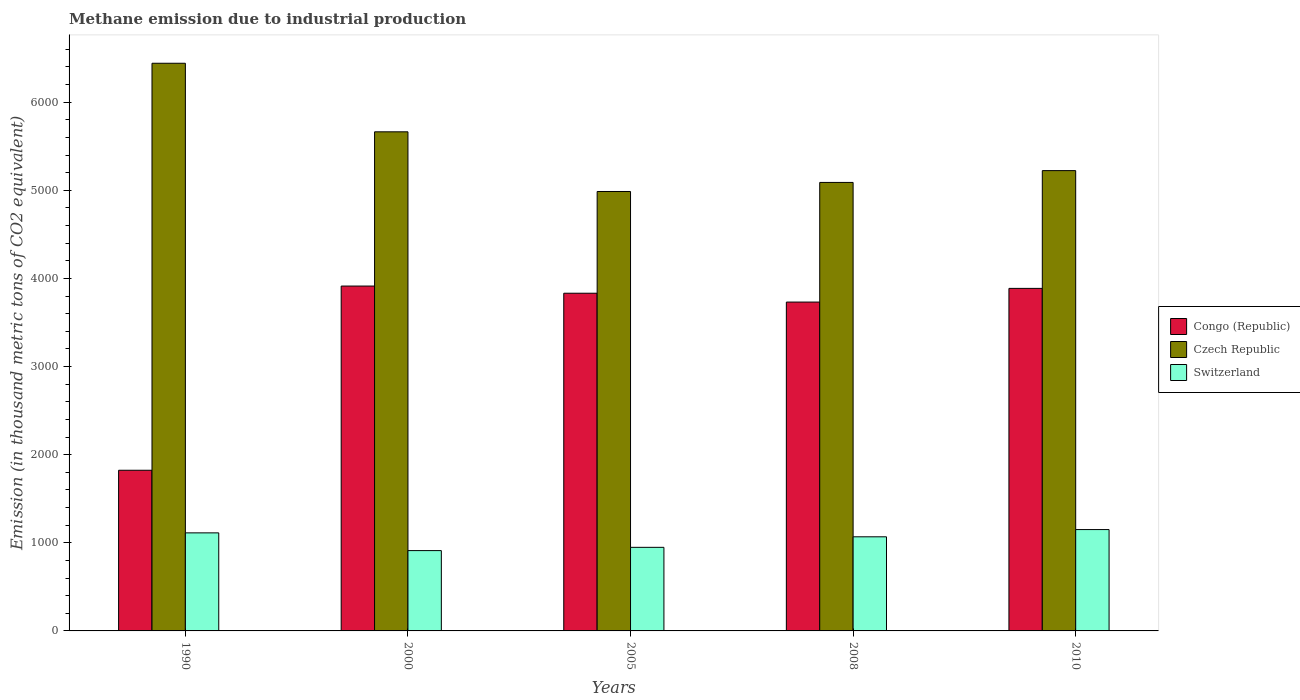How many different coloured bars are there?
Your answer should be compact. 3. How many groups of bars are there?
Provide a succinct answer. 5. Are the number of bars per tick equal to the number of legend labels?
Provide a succinct answer. Yes. Are the number of bars on each tick of the X-axis equal?
Offer a very short reply. Yes. How many bars are there on the 1st tick from the right?
Ensure brevity in your answer.  3. What is the amount of methane emitted in Czech Republic in 1990?
Make the answer very short. 6442.2. Across all years, what is the maximum amount of methane emitted in Switzerland?
Provide a short and direct response. 1150.2. Across all years, what is the minimum amount of methane emitted in Czech Republic?
Offer a terse response. 4986.9. What is the total amount of methane emitted in Congo (Republic) in the graph?
Offer a terse response. 1.72e+04. What is the difference between the amount of methane emitted in Congo (Republic) in 2000 and that in 2005?
Provide a short and direct response. 81.3. What is the difference between the amount of methane emitted in Congo (Republic) in 2000 and the amount of methane emitted in Czech Republic in 1990?
Offer a very short reply. -2528.5. What is the average amount of methane emitted in Czech Republic per year?
Ensure brevity in your answer.  5481.36. In the year 2000, what is the difference between the amount of methane emitted in Congo (Republic) and amount of methane emitted in Switzerland?
Your answer should be very brief. 3002.1. In how many years, is the amount of methane emitted in Czech Republic greater than 5400 thousand metric tons?
Give a very brief answer. 2. What is the ratio of the amount of methane emitted in Congo (Republic) in 2000 to that in 2005?
Provide a succinct answer. 1.02. Is the amount of methane emitted in Switzerland in 1990 less than that in 2000?
Your answer should be compact. No. What is the difference between the highest and the second highest amount of methane emitted in Congo (Republic)?
Provide a succinct answer. 26.4. What is the difference between the highest and the lowest amount of methane emitted in Czech Republic?
Make the answer very short. 1455.3. In how many years, is the amount of methane emitted in Switzerland greater than the average amount of methane emitted in Switzerland taken over all years?
Your answer should be compact. 3. What does the 1st bar from the left in 1990 represents?
Offer a very short reply. Congo (Republic). What does the 2nd bar from the right in 2005 represents?
Ensure brevity in your answer.  Czech Republic. Is it the case that in every year, the sum of the amount of methane emitted in Switzerland and amount of methane emitted in Congo (Republic) is greater than the amount of methane emitted in Czech Republic?
Keep it short and to the point. No. How many bars are there?
Your answer should be compact. 15. Are the values on the major ticks of Y-axis written in scientific E-notation?
Ensure brevity in your answer.  No. Does the graph contain any zero values?
Make the answer very short. No. Does the graph contain grids?
Offer a very short reply. No. Where does the legend appear in the graph?
Offer a very short reply. Center right. How many legend labels are there?
Provide a succinct answer. 3. How are the legend labels stacked?
Your answer should be compact. Vertical. What is the title of the graph?
Your answer should be very brief. Methane emission due to industrial production. Does "Estonia" appear as one of the legend labels in the graph?
Provide a short and direct response. No. What is the label or title of the Y-axis?
Your response must be concise. Emission (in thousand metric tons of CO2 equivalent). What is the Emission (in thousand metric tons of CO2 equivalent) of Congo (Republic) in 1990?
Your answer should be compact. 1823.3. What is the Emission (in thousand metric tons of CO2 equivalent) in Czech Republic in 1990?
Give a very brief answer. 6442.2. What is the Emission (in thousand metric tons of CO2 equivalent) in Switzerland in 1990?
Give a very brief answer. 1112.7. What is the Emission (in thousand metric tons of CO2 equivalent) in Congo (Republic) in 2000?
Offer a terse response. 3913.7. What is the Emission (in thousand metric tons of CO2 equivalent) of Czech Republic in 2000?
Your answer should be compact. 5664.2. What is the Emission (in thousand metric tons of CO2 equivalent) in Switzerland in 2000?
Your answer should be very brief. 911.6. What is the Emission (in thousand metric tons of CO2 equivalent) of Congo (Republic) in 2005?
Keep it short and to the point. 3832.4. What is the Emission (in thousand metric tons of CO2 equivalent) of Czech Republic in 2005?
Your answer should be compact. 4986.9. What is the Emission (in thousand metric tons of CO2 equivalent) of Switzerland in 2005?
Provide a succinct answer. 948.6. What is the Emission (in thousand metric tons of CO2 equivalent) of Congo (Republic) in 2008?
Provide a short and direct response. 3732. What is the Emission (in thousand metric tons of CO2 equivalent) in Czech Republic in 2008?
Provide a succinct answer. 5089.7. What is the Emission (in thousand metric tons of CO2 equivalent) of Switzerland in 2008?
Keep it short and to the point. 1068.1. What is the Emission (in thousand metric tons of CO2 equivalent) in Congo (Republic) in 2010?
Provide a succinct answer. 3887.3. What is the Emission (in thousand metric tons of CO2 equivalent) of Czech Republic in 2010?
Make the answer very short. 5223.8. What is the Emission (in thousand metric tons of CO2 equivalent) in Switzerland in 2010?
Make the answer very short. 1150.2. Across all years, what is the maximum Emission (in thousand metric tons of CO2 equivalent) of Congo (Republic)?
Offer a terse response. 3913.7. Across all years, what is the maximum Emission (in thousand metric tons of CO2 equivalent) of Czech Republic?
Ensure brevity in your answer.  6442.2. Across all years, what is the maximum Emission (in thousand metric tons of CO2 equivalent) of Switzerland?
Keep it short and to the point. 1150.2. Across all years, what is the minimum Emission (in thousand metric tons of CO2 equivalent) of Congo (Republic)?
Your response must be concise. 1823.3. Across all years, what is the minimum Emission (in thousand metric tons of CO2 equivalent) of Czech Republic?
Make the answer very short. 4986.9. Across all years, what is the minimum Emission (in thousand metric tons of CO2 equivalent) of Switzerland?
Offer a terse response. 911.6. What is the total Emission (in thousand metric tons of CO2 equivalent) of Congo (Republic) in the graph?
Ensure brevity in your answer.  1.72e+04. What is the total Emission (in thousand metric tons of CO2 equivalent) in Czech Republic in the graph?
Your response must be concise. 2.74e+04. What is the total Emission (in thousand metric tons of CO2 equivalent) in Switzerland in the graph?
Keep it short and to the point. 5191.2. What is the difference between the Emission (in thousand metric tons of CO2 equivalent) in Congo (Republic) in 1990 and that in 2000?
Offer a terse response. -2090.4. What is the difference between the Emission (in thousand metric tons of CO2 equivalent) in Czech Republic in 1990 and that in 2000?
Your answer should be compact. 778. What is the difference between the Emission (in thousand metric tons of CO2 equivalent) in Switzerland in 1990 and that in 2000?
Provide a short and direct response. 201.1. What is the difference between the Emission (in thousand metric tons of CO2 equivalent) of Congo (Republic) in 1990 and that in 2005?
Keep it short and to the point. -2009.1. What is the difference between the Emission (in thousand metric tons of CO2 equivalent) of Czech Republic in 1990 and that in 2005?
Your answer should be compact. 1455.3. What is the difference between the Emission (in thousand metric tons of CO2 equivalent) in Switzerland in 1990 and that in 2005?
Your answer should be compact. 164.1. What is the difference between the Emission (in thousand metric tons of CO2 equivalent) of Congo (Republic) in 1990 and that in 2008?
Ensure brevity in your answer.  -1908.7. What is the difference between the Emission (in thousand metric tons of CO2 equivalent) of Czech Republic in 1990 and that in 2008?
Your response must be concise. 1352.5. What is the difference between the Emission (in thousand metric tons of CO2 equivalent) of Switzerland in 1990 and that in 2008?
Keep it short and to the point. 44.6. What is the difference between the Emission (in thousand metric tons of CO2 equivalent) of Congo (Republic) in 1990 and that in 2010?
Your response must be concise. -2064. What is the difference between the Emission (in thousand metric tons of CO2 equivalent) in Czech Republic in 1990 and that in 2010?
Offer a terse response. 1218.4. What is the difference between the Emission (in thousand metric tons of CO2 equivalent) in Switzerland in 1990 and that in 2010?
Ensure brevity in your answer.  -37.5. What is the difference between the Emission (in thousand metric tons of CO2 equivalent) of Congo (Republic) in 2000 and that in 2005?
Your answer should be very brief. 81.3. What is the difference between the Emission (in thousand metric tons of CO2 equivalent) of Czech Republic in 2000 and that in 2005?
Make the answer very short. 677.3. What is the difference between the Emission (in thousand metric tons of CO2 equivalent) of Switzerland in 2000 and that in 2005?
Your answer should be compact. -37. What is the difference between the Emission (in thousand metric tons of CO2 equivalent) of Congo (Republic) in 2000 and that in 2008?
Your answer should be compact. 181.7. What is the difference between the Emission (in thousand metric tons of CO2 equivalent) of Czech Republic in 2000 and that in 2008?
Your answer should be compact. 574.5. What is the difference between the Emission (in thousand metric tons of CO2 equivalent) of Switzerland in 2000 and that in 2008?
Ensure brevity in your answer.  -156.5. What is the difference between the Emission (in thousand metric tons of CO2 equivalent) of Congo (Republic) in 2000 and that in 2010?
Ensure brevity in your answer.  26.4. What is the difference between the Emission (in thousand metric tons of CO2 equivalent) in Czech Republic in 2000 and that in 2010?
Provide a short and direct response. 440.4. What is the difference between the Emission (in thousand metric tons of CO2 equivalent) in Switzerland in 2000 and that in 2010?
Provide a short and direct response. -238.6. What is the difference between the Emission (in thousand metric tons of CO2 equivalent) in Congo (Republic) in 2005 and that in 2008?
Offer a very short reply. 100.4. What is the difference between the Emission (in thousand metric tons of CO2 equivalent) of Czech Republic in 2005 and that in 2008?
Your answer should be compact. -102.8. What is the difference between the Emission (in thousand metric tons of CO2 equivalent) of Switzerland in 2005 and that in 2008?
Your response must be concise. -119.5. What is the difference between the Emission (in thousand metric tons of CO2 equivalent) in Congo (Republic) in 2005 and that in 2010?
Keep it short and to the point. -54.9. What is the difference between the Emission (in thousand metric tons of CO2 equivalent) in Czech Republic in 2005 and that in 2010?
Provide a short and direct response. -236.9. What is the difference between the Emission (in thousand metric tons of CO2 equivalent) in Switzerland in 2005 and that in 2010?
Ensure brevity in your answer.  -201.6. What is the difference between the Emission (in thousand metric tons of CO2 equivalent) of Congo (Republic) in 2008 and that in 2010?
Your answer should be compact. -155.3. What is the difference between the Emission (in thousand metric tons of CO2 equivalent) of Czech Republic in 2008 and that in 2010?
Offer a very short reply. -134.1. What is the difference between the Emission (in thousand metric tons of CO2 equivalent) of Switzerland in 2008 and that in 2010?
Provide a short and direct response. -82.1. What is the difference between the Emission (in thousand metric tons of CO2 equivalent) in Congo (Republic) in 1990 and the Emission (in thousand metric tons of CO2 equivalent) in Czech Republic in 2000?
Your answer should be compact. -3840.9. What is the difference between the Emission (in thousand metric tons of CO2 equivalent) in Congo (Republic) in 1990 and the Emission (in thousand metric tons of CO2 equivalent) in Switzerland in 2000?
Provide a succinct answer. 911.7. What is the difference between the Emission (in thousand metric tons of CO2 equivalent) in Czech Republic in 1990 and the Emission (in thousand metric tons of CO2 equivalent) in Switzerland in 2000?
Make the answer very short. 5530.6. What is the difference between the Emission (in thousand metric tons of CO2 equivalent) of Congo (Republic) in 1990 and the Emission (in thousand metric tons of CO2 equivalent) of Czech Republic in 2005?
Offer a very short reply. -3163.6. What is the difference between the Emission (in thousand metric tons of CO2 equivalent) in Congo (Republic) in 1990 and the Emission (in thousand metric tons of CO2 equivalent) in Switzerland in 2005?
Provide a succinct answer. 874.7. What is the difference between the Emission (in thousand metric tons of CO2 equivalent) of Czech Republic in 1990 and the Emission (in thousand metric tons of CO2 equivalent) of Switzerland in 2005?
Your answer should be compact. 5493.6. What is the difference between the Emission (in thousand metric tons of CO2 equivalent) in Congo (Republic) in 1990 and the Emission (in thousand metric tons of CO2 equivalent) in Czech Republic in 2008?
Provide a short and direct response. -3266.4. What is the difference between the Emission (in thousand metric tons of CO2 equivalent) of Congo (Republic) in 1990 and the Emission (in thousand metric tons of CO2 equivalent) of Switzerland in 2008?
Your answer should be compact. 755.2. What is the difference between the Emission (in thousand metric tons of CO2 equivalent) of Czech Republic in 1990 and the Emission (in thousand metric tons of CO2 equivalent) of Switzerland in 2008?
Offer a terse response. 5374.1. What is the difference between the Emission (in thousand metric tons of CO2 equivalent) in Congo (Republic) in 1990 and the Emission (in thousand metric tons of CO2 equivalent) in Czech Republic in 2010?
Provide a succinct answer. -3400.5. What is the difference between the Emission (in thousand metric tons of CO2 equivalent) in Congo (Republic) in 1990 and the Emission (in thousand metric tons of CO2 equivalent) in Switzerland in 2010?
Keep it short and to the point. 673.1. What is the difference between the Emission (in thousand metric tons of CO2 equivalent) in Czech Republic in 1990 and the Emission (in thousand metric tons of CO2 equivalent) in Switzerland in 2010?
Keep it short and to the point. 5292. What is the difference between the Emission (in thousand metric tons of CO2 equivalent) of Congo (Republic) in 2000 and the Emission (in thousand metric tons of CO2 equivalent) of Czech Republic in 2005?
Offer a very short reply. -1073.2. What is the difference between the Emission (in thousand metric tons of CO2 equivalent) in Congo (Republic) in 2000 and the Emission (in thousand metric tons of CO2 equivalent) in Switzerland in 2005?
Your answer should be compact. 2965.1. What is the difference between the Emission (in thousand metric tons of CO2 equivalent) of Czech Republic in 2000 and the Emission (in thousand metric tons of CO2 equivalent) of Switzerland in 2005?
Provide a succinct answer. 4715.6. What is the difference between the Emission (in thousand metric tons of CO2 equivalent) in Congo (Republic) in 2000 and the Emission (in thousand metric tons of CO2 equivalent) in Czech Republic in 2008?
Offer a terse response. -1176. What is the difference between the Emission (in thousand metric tons of CO2 equivalent) in Congo (Republic) in 2000 and the Emission (in thousand metric tons of CO2 equivalent) in Switzerland in 2008?
Offer a terse response. 2845.6. What is the difference between the Emission (in thousand metric tons of CO2 equivalent) of Czech Republic in 2000 and the Emission (in thousand metric tons of CO2 equivalent) of Switzerland in 2008?
Offer a terse response. 4596.1. What is the difference between the Emission (in thousand metric tons of CO2 equivalent) in Congo (Republic) in 2000 and the Emission (in thousand metric tons of CO2 equivalent) in Czech Republic in 2010?
Your answer should be compact. -1310.1. What is the difference between the Emission (in thousand metric tons of CO2 equivalent) in Congo (Republic) in 2000 and the Emission (in thousand metric tons of CO2 equivalent) in Switzerland in 2010?
Give a very brief answer. 2763.5. What is the difference between the Emission (in thousand metric tons of CO2 equivalent) of Czech Republic in 2000 and the Emission (in thousand metric tons of CO2 equivalent) of Switzerland in 2010?
Provide a short and direct response. 4514. What is the difference between the Emission (in thousand metric tons of CO2 equivalent) of Congo (Republic) in 2005 and the Emission (in thousand metric tons of CO2 equivalent) of Czech Republic in 2008?
Ensure brevity in your answer.  -1257.3. What is the difference between the Emission (in thousand metric tons of CO2 equivalent) in Congo (Republic) in 2005 and the Emission (in thousand metric tons of CO2 equivalent) in Switzerland in 2008?
Provide a short and direct response. 2764.3. What is the difference between the Emission (in thousand metric tons of CO2 equivalent) of Czech Republic in 2005 and the Emission (in thousand metric tons of CO2 equivalent) of Switzerland in 2008?
Keep it short and to the point. 3918.8. What is the difference between the Emission (in thousand metric tons of CO2 equivalent) in Congo (Republic) in 2005 and the Emission (in thousand metric tons of CO2 equivalent) in Czech Republic in 2010?
Ensure brevity in your answer.  -1391.4. What is the difference between the Emission (in thousand metric tons of CO2 equivalent) of Congo (Republic) in 2005 and the Emission (in thousand metric tons of CO2 equivalent) of Switzerland in 2010?
Offer a very short reply. 2682.2. What is the difference between the Emission (in thousand metric tons of CO2 equivalent) of Czech Republic in 2005 and the Emission (in thousand metric tons of CO2 equivalent) of Switzerland in 2010?
Your answer should be compact. 3836.7. What is the difference between the Emission (in thousand metric tons of CO2 equivalent) of Congo (Republic) in 2008 and the Emission (in thousand metric tons of CO2 equivalent) of Czech Republic in 2010?
Offer a very short reply. -1491.8. What is the difference between the Emission (in thousand metric tons of CO2 equivalent) of Congo (Republic) in 2008 and the Emission (in thousand metric tons of CO2 equivalent) of Switzerland in 2010?
Your response must be concise. 2581.8. What is the difference between the Emission (in thousand metric tons of CO2 equivalent) of Czech Republic in 2008 and the Emission (in thousand metric tons of CO2 equivalent) of Switzerland in 2010?
Your response must be concise. 3939.5. What is the average Emission (in thousand metric tons of CO2 equivalent) of Congo (Republic) per year?
Offer a very short reply. 3437.74. What is the average Emission (in thousand metric tons of CO2 equivalent) of Czech Republic per year?
Offer a terse response. 5481.36. What is the average Emission (in thousand metric tons of CO2 equivalent) in Switzerland per year?
Keep it short and to the point. 1038.24. In the year 1990, what is the difference between the Emission (in thousand metric tons of CO2 equivalent) of Congo (Republic) and Emission (in thousand metric tons of CO2 equivalent) of Czech Republic?
Offer a very short reply. -4618.9. In the year 1990, what is the difference between the Emission (in thousand metric tons of CO2 equivalent) of Congo (Republic) and Emission (in thousand metric tons of CO2 equivalent) of Switzerland?
Make the answer very short. 710.6. In the year 1990, what is the difference between the Emission (in thousand metric tons of CO2 equivalent) in Czech Republic and Emission (in thousand metric tons of CO2 equivalent) in Switzerland?
Provide a short and direct response. 5329.5. In the year 2000, what is the difference between the Emission (in thousand metric tons of CO2 equivalent) in Congo (Republic) and Emission (in thousand metric tons of CO2 equivalent) in Czech Republic?
Offer a very short reply. -1750.5. In the year 2000, what is the difference between the Emission (in thousand metric tons of CO2 equivalent) of Congo (Republic) and Emission (in thousand metric tons of CO2 equivalent) of Switzerland?
Provide a short and direct response. 3002.1. In the year 2000, what is the difference between the Emission (in thousand metric tons of CO2 equivalent) of Czech Republic and Emission (in thousand metric tons of CO2 equivalent) of Switzerland?
Your response must be concise. 4752.6. In the year 2005, what is the difference between the Emission (in thousand metric tons of CO2 equivalent) in Congo (Republic) and Emission (in thousand metric tons of CO2 equivalent) in Czech Republic?
Provide a succinct answer. -1154.5. In the year 2005, what is the difference between the Emission (in thousand metric tons of CO2 equivalent) of Congo (Republic) and Emission (in thousand metric tons of CO2 equivalent) of Switzerland?
Keep it short and to the point. 2883.8. In the year 2005, what is the difference between the Emission (in thousand metric tons of CO2 equivalent) in Czech Republic and Emission (in thousand metric tons of CO2 equivalent) in Switzerland?
Give a very brief answer. 4038.3. In the year 2008, what is the difference between the Emission (in thousand metric tons of CO2 equivalent) in Congo (Republic) and Emission (in thousand metric tons of CO2 equivalent) in Czech Republic?
Provide a succinct answer. -1357.7. In the year 2008, what is the difference between the Emission (in thousand metric tons of CO2 equivalent) in Congo (Republic) and Emission (in thousand metric tons of CO2 equivalent) in Switzerland?
Offer a terse response. 2663.9. In the year 2008, what is the difference between the Emission (in thousand metric tons of CO2 equivalent) of Czech Republic and Emission (in thousand metric tons of CO2 equivalent) of Switzerland?
Offer a terse response. 4021.6. In the year 2010, what is the difference between the Emission (in thousand metric tons of CO2 equivalent) in Congo (Republic) and Emission (in thousand metric tons of CO2 equivalent) in Czech Republic?
Your answer should be very brief. -1336.5. In the year 2010, what is the difference between the Emission (in thousand metric tons of CO2 equivalent) in Congo (Republic) and Emission (in thousand metric tons of CO2 equivalent) in Switzerland?
Keep it short and to the point. 2737.1. In the year 2010, what is the difference between the Emission (in thousand metric tons of CO2 equivalent) in Czech Republic and Emission (in thousand metric tons of CO2 equivalent) in Switzerland?
Give a very brief answer. 4073.6. What is the ratio of the Emission (in thousand metric tons of CO2 equivalent) of Congo (Republic) in 1990 to that in 2000?
Give a very brief answer. 0.47. What is the ratio of the Emission (in thousand metric tons of CO2 equivalent) of Czech Republic in 1990 to that in 2000?
Offer a terse response. 1.14. What is the ratio of the Emission (in thousand metric tons of CO2 equivalent) of Switzerland in 1990 to that in 2000?
Offer a terse response. 1.22. What is the ratio of the Emission (in thousand metric tons of CO2 equivalent) of Congo (Republic) in 1990 to that in 2005?
Your response must be concise. 0.48. What is the ratio of the Emission (in thousand metric tons of CO2 equivalent) of Czech Republic in 1990 to that in 2005?
Offer a very short reply. 1.29. What is the ratio of the Emission (in thousand metric tons of CO2 equivalent) in Switzerland in 1990 to that in 2005?
Your answer should be very brief. 1.17. What is the ratio of the Emission (in thousand metric tons of CO2 equivalent) of Congo (Republic) in 1990 to that in 2008?
Your response must be concise. 0.49. What is the ratio of the Emission (in thousand metric tons of CO2 equivalent) in Czech Republic in 1990 to that in 2008?
Make the answer very short. 1.27. What is the ratio of the Emission (in thousand metric tons of CO2 equivalent) in Switzerland in 1990 to that in 2008?
Your answer should be compact. 1.04. What is the ratio of the Emission (in thousand metric tons of CO2 equivalent) in Congo (Republic) in 1990 to that in 2010?
Ensure brevity in your answer.  0.47. What is the ratio of the Emission (in thousand metric tons of CO2 equivalent) in Czech Republic in 1990 to that in 2010?
Your response must be concise. 1.23. What is the ratio of the Emission (in thousand metric tons of CO2 equivalent) of Switzerland in 1990 to that in 2010?
Your response must be concise. 0.97. What is the ratio of the Emission (in thousand metric tons of CO2 equivalent) of Congo (Republic) in 2000 to that in 2005?
Your answer should be very brief. 1.02. What is the ratio of the Emission (in thousand metric tons of CO2 equivalent) of Czech Republic in 2000 to that in 2005?
Ensure brevity in your answer.  1.14. What is the ratio of the Emission (in thousand metric tons of CO2 equivalent) of Switzerland in 2000 to that in 2005?
Your answer should be very brief. 0.96. What is the ratio of the Emission (in thousand metric tons of CO2 equivalent) in Congo (Republic) in 2000 to that in 2008?
Provide a succinct answer. 1.05. What is the ratio of the Emission (in thousand metric tons of CO2 equivalent) in Czech Republic in 2000 to that in 2008?
Your answer should be very brief. 1.11. What is the ratio of the Emission (in thousand metric tons of CO2 equivalent) of Switzerland in 2000 to that in 2008?
Your answer should be very brief. 0.85. What is the ratio of the Emission (in thousand metric tons of CO2 equivalent) in Congo (Republic) in 2000 to that in 2010?
Offer a terse response. 1.01. What is the ratio of the Emission (in thousand metric tons of CO2 equivalent) in Czech Republic in 2000 to that in 2010?
Provide a short and direct response. 1.08. What is the ratio of the Emission (in thousand metric tons of CO2 equivalent) in Switzerland in 2000 to that in 2010?
Provide a succinct answer. 0.79. What is the ratio of the Emission (in thousand metric tons of CO2 equivalent) in Congo (Republic) in 2005 to that in 2008?
Make the answer very short. 1.03. What is the ratio of the Emission (in thousand metric tons of CO2 equivalent) of Czech Republic in 2005 to that in 2008?
Offer a very short reply. 0.98. What is the ratio of the Emission (in thousand metric tons of CO2 equivalent) in Switzerland in 2005 to that in 2008?
Keep it short and to the point. 0.89. What is the ratio of the Emission (in thousand metric tons of CO2 equivalent) of Congo (Republic) in 2005 to that in 2010?
Your answer should be very brief. 0.99. What is the ratio of the Emission (in thousand metric tons of CO2 equivalent) in Czech Republic in 2005 to that in 2010?
Offer a terse response. 0.95. What is the ratio of the Emission (in thousand metric tons of CO2 equivalent) of Switzerland in 2005 to that in 2010?
Your answer should be compact. 0.82. What is the ratio of the Emission (in thousand metric tons of CO2 equivalent) of Congo (Republic) in 2008 to that in 2010?
Make the answer very short. 0.96. What is the ratio of the Emission (in thousand metric tons of CO2 equivalent) in Czech Republic in 2008 to that in 2010?
Give a very brief answer. 0.97. What is the difference between the highest and the second highest Emission (in thousand metric tons of CO2 equivalent) in Congo (Republic)?
Provide a short and direct response. 26.4. What is the difference between the highest and the second highest Emission (in thousand metric tons of CO2 equivalent) in Czech Republic?
Your answer should be compact. 778. What is the difference between the highest and the second highest Emission (in thousand metric tons of CO2 equivalent) of Switzerland?
Make the answer very short. 37.5. What is the difference between the highest and the lowest Emission (in thousand metric tons of CO2 equivalent) of Congo (Republic)?
Your answer should be very brief. 2090.4. What is the difference between the highest and the lowest Emission (in thousand metric tons of CO2 equivalent) in Czech Republic?
Provide a succinct answer. 1455.3. What is the difference between the highest and the lowest Emission (in thousand metric tons of CO2 equivalent) of Switzerland?
Give a very brief answer. 238.6. 